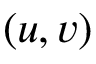<formula> <loc_0><loc_0><loc_500><loc_500>\left ( u , v \right )</formula> 